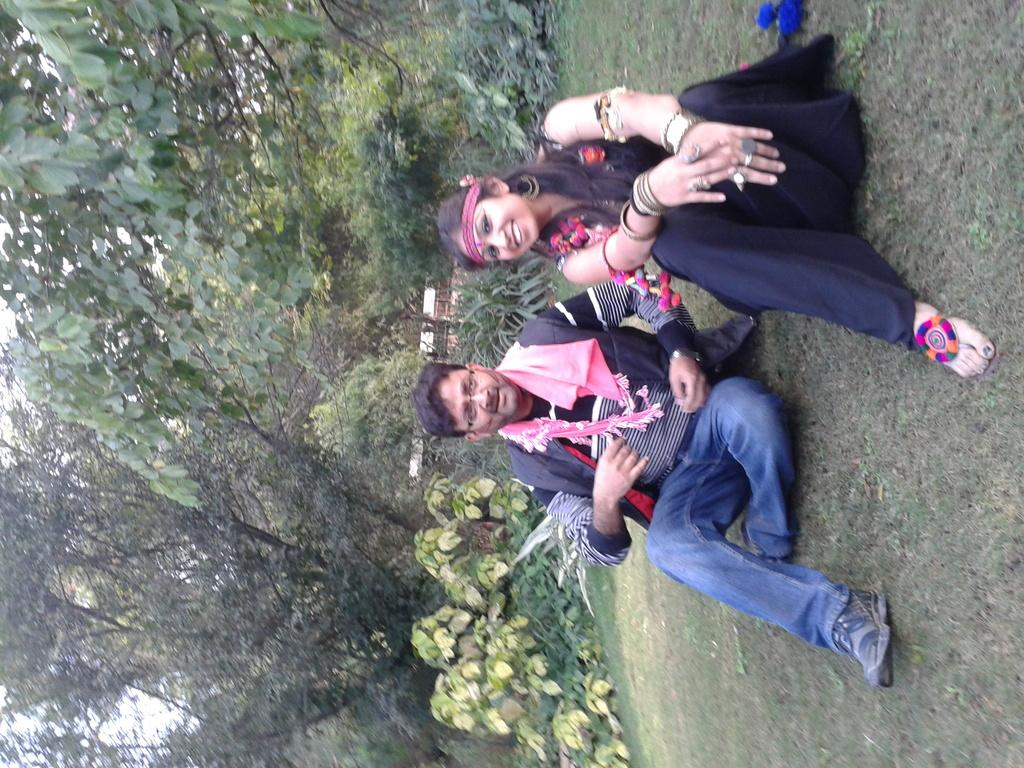How many people can be seen in the image? There are a few people in the image. What type of surface is visible under the people's feet? The ground is visible in the image. What type of vegetation is present in the image? There is grass, plants, and trees in the image. What color is the white colored object in the image? The white colored object in the image is not specified, so we cannot determine its color. What part of the natural environment is visible in the image? The sky is visible in the image. How many credits are required to purchase the screw in the image? There is no screw or any indication of a purchase in the image. 